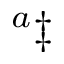Convert formula to latex. <formula><loc_0><loc_0><loc_500><loc_500>^ { a } \ddag</formula> 